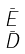Convert formula to latex. <formula><loc_0><loc_0><loc_500><loc_500>\begin{smallmatrix} \bar { E } \\ \bar { D } \end{smallmatrix}</formula> 